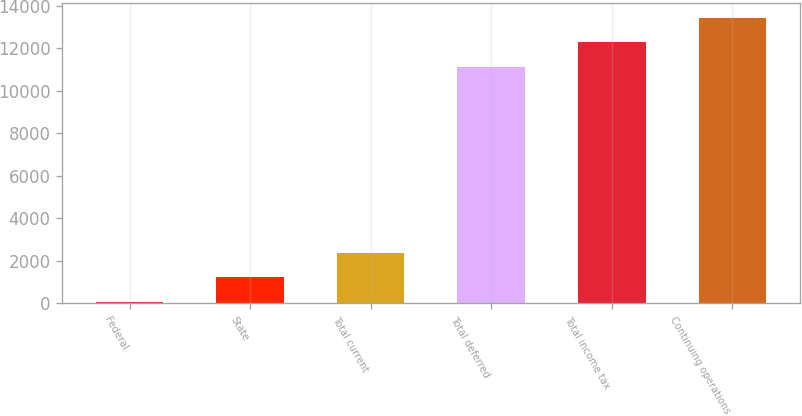Convert chart to OTSL. <chart><loc_0><loc_0><loc_500><loc_500><bar_chart><fcel>Federal<fcel>State<fcel>Total current<fcel>Total deferred<fcel>Total income tax<fcel>Continuing operations<nl><fcel>69<fcel>1219.5<fcel>2370<fcel>11133<fcel>12283.5<fcel>13434<nl></chart> 